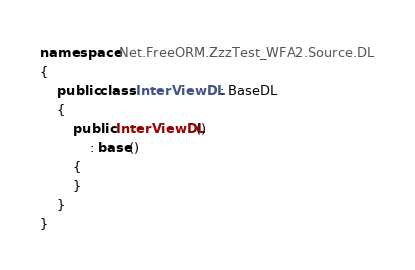Convert code to text. <code><loc_0><loc_0><loc_500><loc_500><_C#_>
namespace Net.FreeORM.ZzzTest_WFA2.Source.DL
{
	public class InterViewDL : BaseDL
	{
		public InterViewDL()
			: base()
		{
		}
	}
}
</code> 